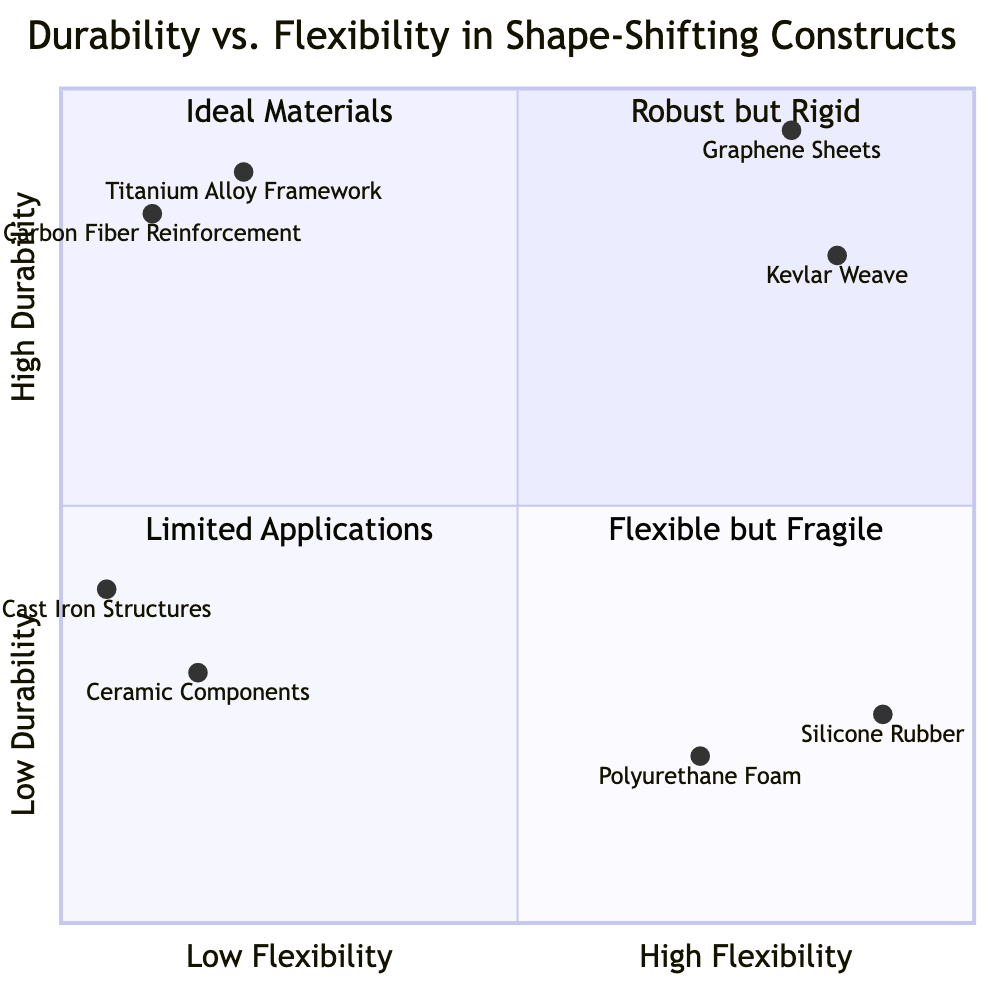What materials are in the "High Durability, Low Flexibility" quadrant? The "High Durability, Low Flexibility" quadrant contains two materials: "Titanium Alloy Framework" and "Carbon Fiber Reinforcement." This can be found by directly referencing the quadrant marked in the diagram.
Answer: Titanium Alloy Framework, Carbon Fiber Reinforcement How many materials are in the "Low Durability, High Flexibility" quadrant? The "Low Durability, High Flexibility" quadrant consists of two materials: "Polyurethane Foam" and "Silicone Rubber." Counting these entries gives us the total.
Answer: 2 Which material has the highest durability? The material with the highest durability, located in the upper quadrants, is "Graphene Sheets." This conclusion comes from identifying the highest point on the y-axis within the diagram's structure.
Answer: Graphene Sheets Which quadrant contains "Cast Iron Structures"? "Cast Iron Structures" are located in the "Low Durability, Low Flexibility" quadrant. This can be determined by locating the name within the appropriate area of the diagram, which deals with low values on both the x and y axes.
Answer: Low Durability, Low Flexibility What is the y-axis value for "Kevlar Weave"? The y-axis value for "Kevlar Weave" is 0.8. This result comes from locating the position of "Kevlar Weave" on the diagram and reading its corresponding value on the y-axis.
Answer: 0.8 How do "Graphene Sheets" compare to "Titanium Alloy Framework" in terms of flexibility? "Graphene Sheets," positioned further right in the diagram at a value of 0.8, demonstrate higher flexibility than "Titanium Alloy Framework," which is at 0.2. Analysis of their respective x-axis values confirms this.
Answer: More flexible than Which material has the lowest durability? The material with the lowest durability is "Polyurethane Foam," situated in the "Low Durability, High Flexibility" quadrant. This assessment is based on identifying the lowest point on the y-axis across all materials depicted.
Answer: Polyurethane Foam How many materials are categorized as "Flexible but Fragile"? There are two materials categorized as "Flexible but Fragile": "Polyurethane Foam" and "Silicone Rubber." We arrive at this total by counting the entries within this specific quadrant in the diagram.
Answer: 2 